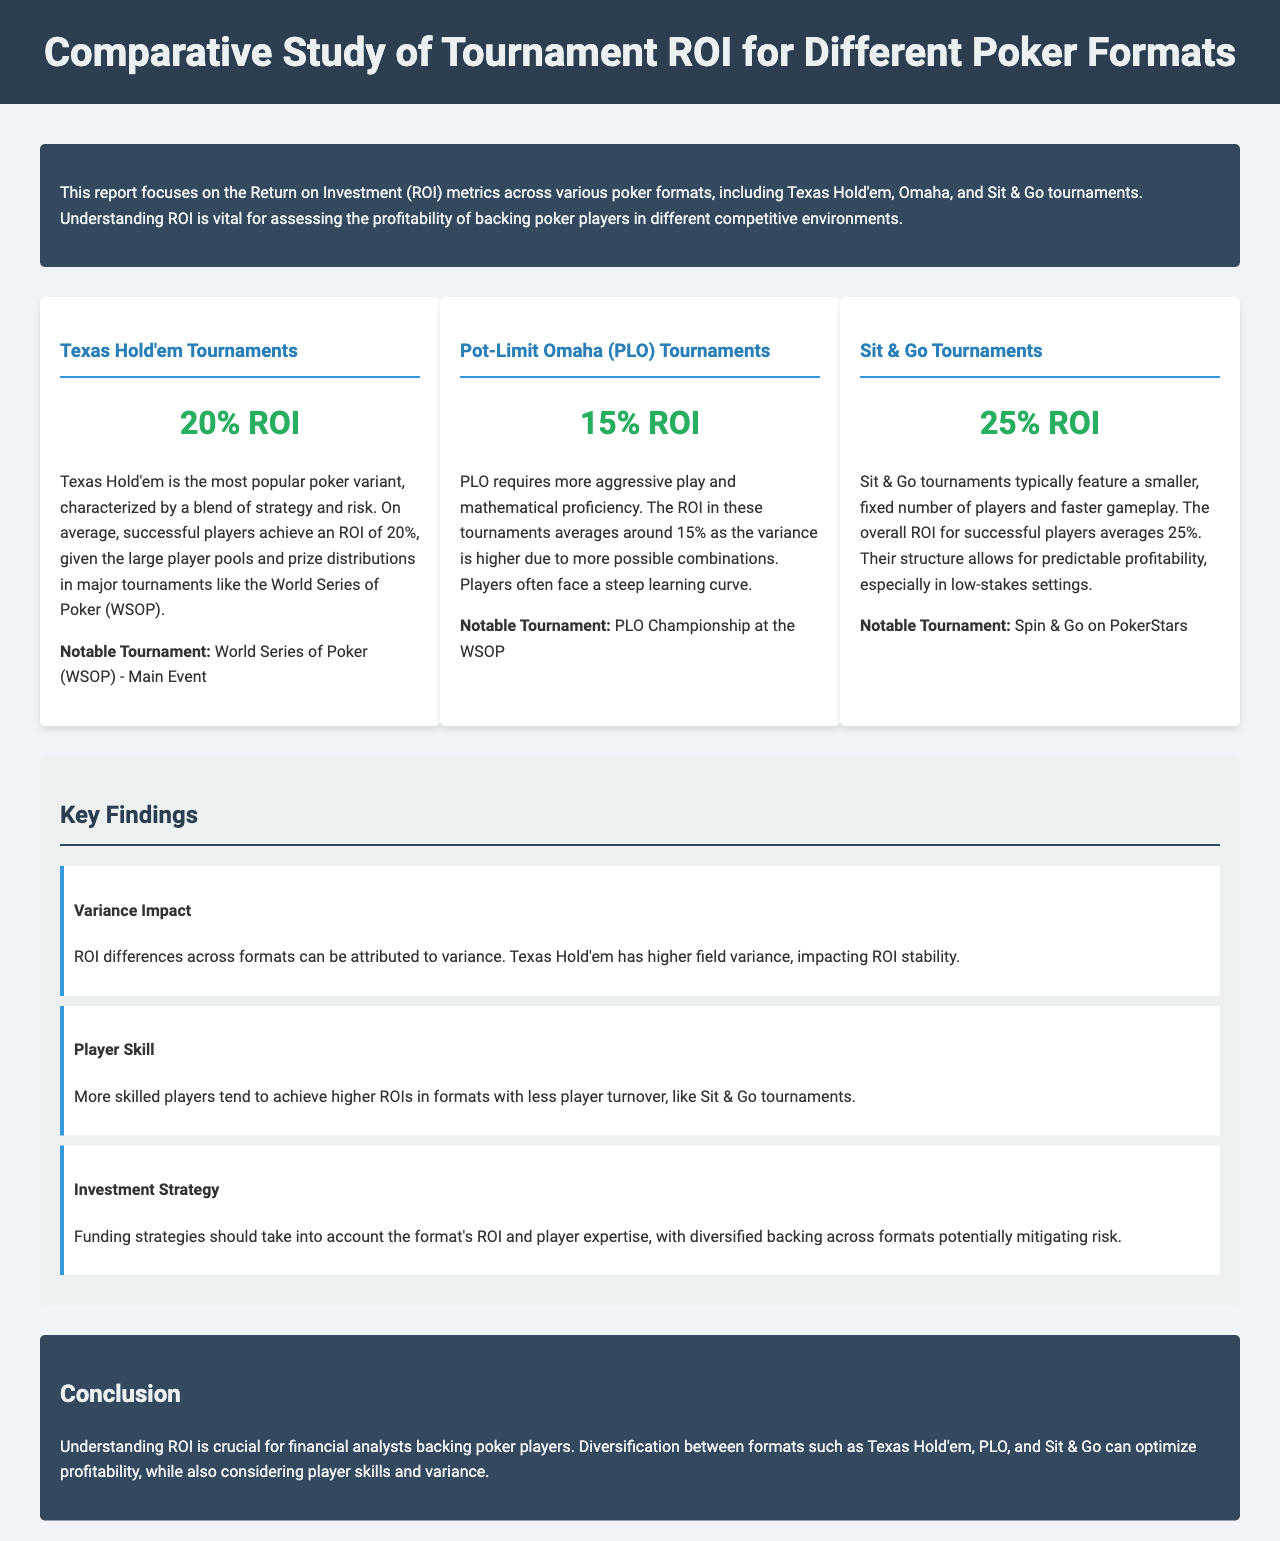What is the ROI for Texas Hold'em tournaments? The document states that the ROI for Texas Hold'em tournaments is 20%.
Answer: 20% What notable tournament is mentioned for Pot-Limit Omaha? The document specifies the PLO Championship at the WSOP as the notable tournament for Pot-Limit Omaha.
Answer: PLO Championship at the WSOP What is the ROI for Sit & Go tournaments? According to the report, the ROI for Sit & Go tournaments averages 25%.
Answer: 25% What is one factor affecting ROI variance in Texas Hold'em? The document mentions that higher field variance impacts ROI stability in Texas Hold'em.
Answer: Higher field variance In which poker format do more skilled players achieve higher ROIs? The analysis points out that more skilled players achieve higher ROIs in Sit & Go tournaments.
Answer: Sit & Go tournaments What are funding strategies recommended to mitigate risk? The report advises that funding strategies should account for format ROI and player expertise, suggesting diversified backing across formats.
Answer: Diversified backing across formats What is the conclusion regarding the importance of understanding ROI? The document concludes that understanding ROI is crucial for financial analysts backing poker players.
Answer: Crucial for financial analysts What does the report highlight about the structure of Sit & Go tournaments? The report states that Sit & Go tournaments have a smaller, fixed number of players and faster gameplay, which contributes to profitability.
Answer: Smaller, fixed number of players and faster gameplay 